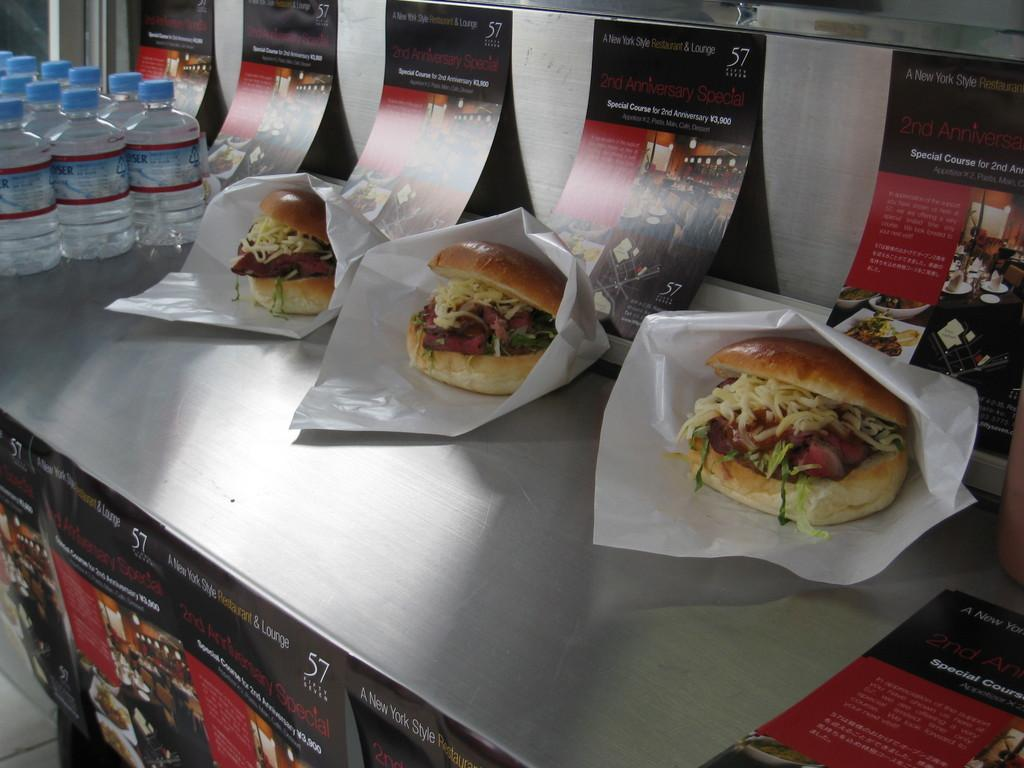What is the main object in the center of the image? There is a desk in the center of the image. What items can be seen on the desk? There are water bottles and burgers on the desk. What is present at the top and bottom of the image? There are posters at the top and bottom of the image. How many credits are visible on the desk in the image? There are no credits present on the desk in the image. What type of twig can be seen growing from the burgers in the image? There are no twigs present on the burgers in the image. 